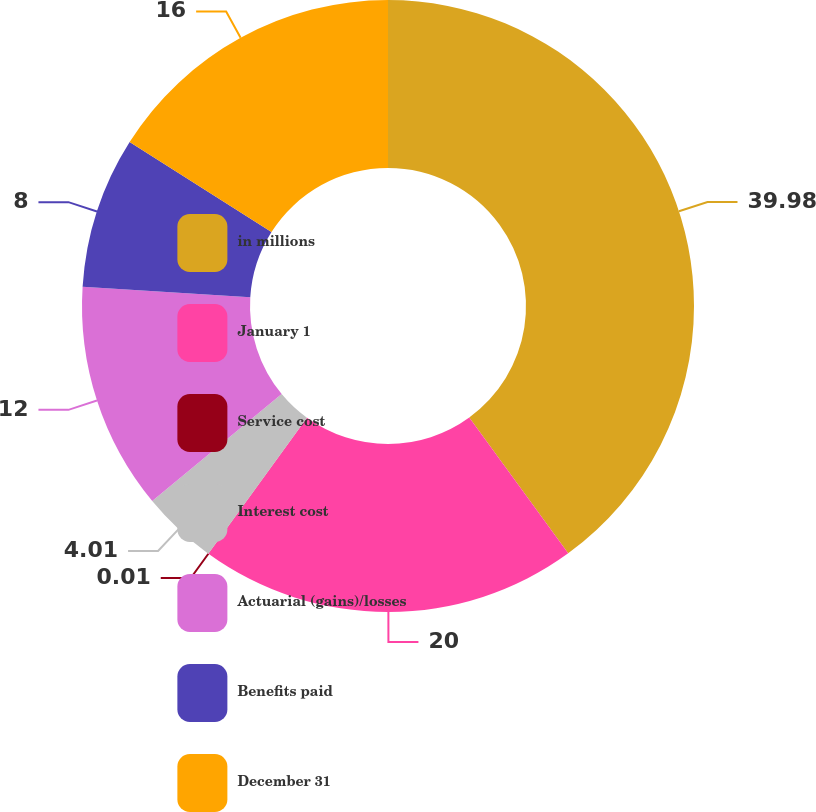<chart> <loc_0><loc_0><loc_500><loc_500><pie_chart><fcel>in millions<fcel>January 1<fcel>Service cost<fcel>Interest cost<fcel>Actuarial (gains)/losses<fcel>Benefits paid<fcel>December 31<nl><fcel>39.98%<fcel>20.0%<fcel>0.01%<fcel>4.01%<fcel>12.0%<fcel>8.0%<fcel>16.0%<nl></chart> 